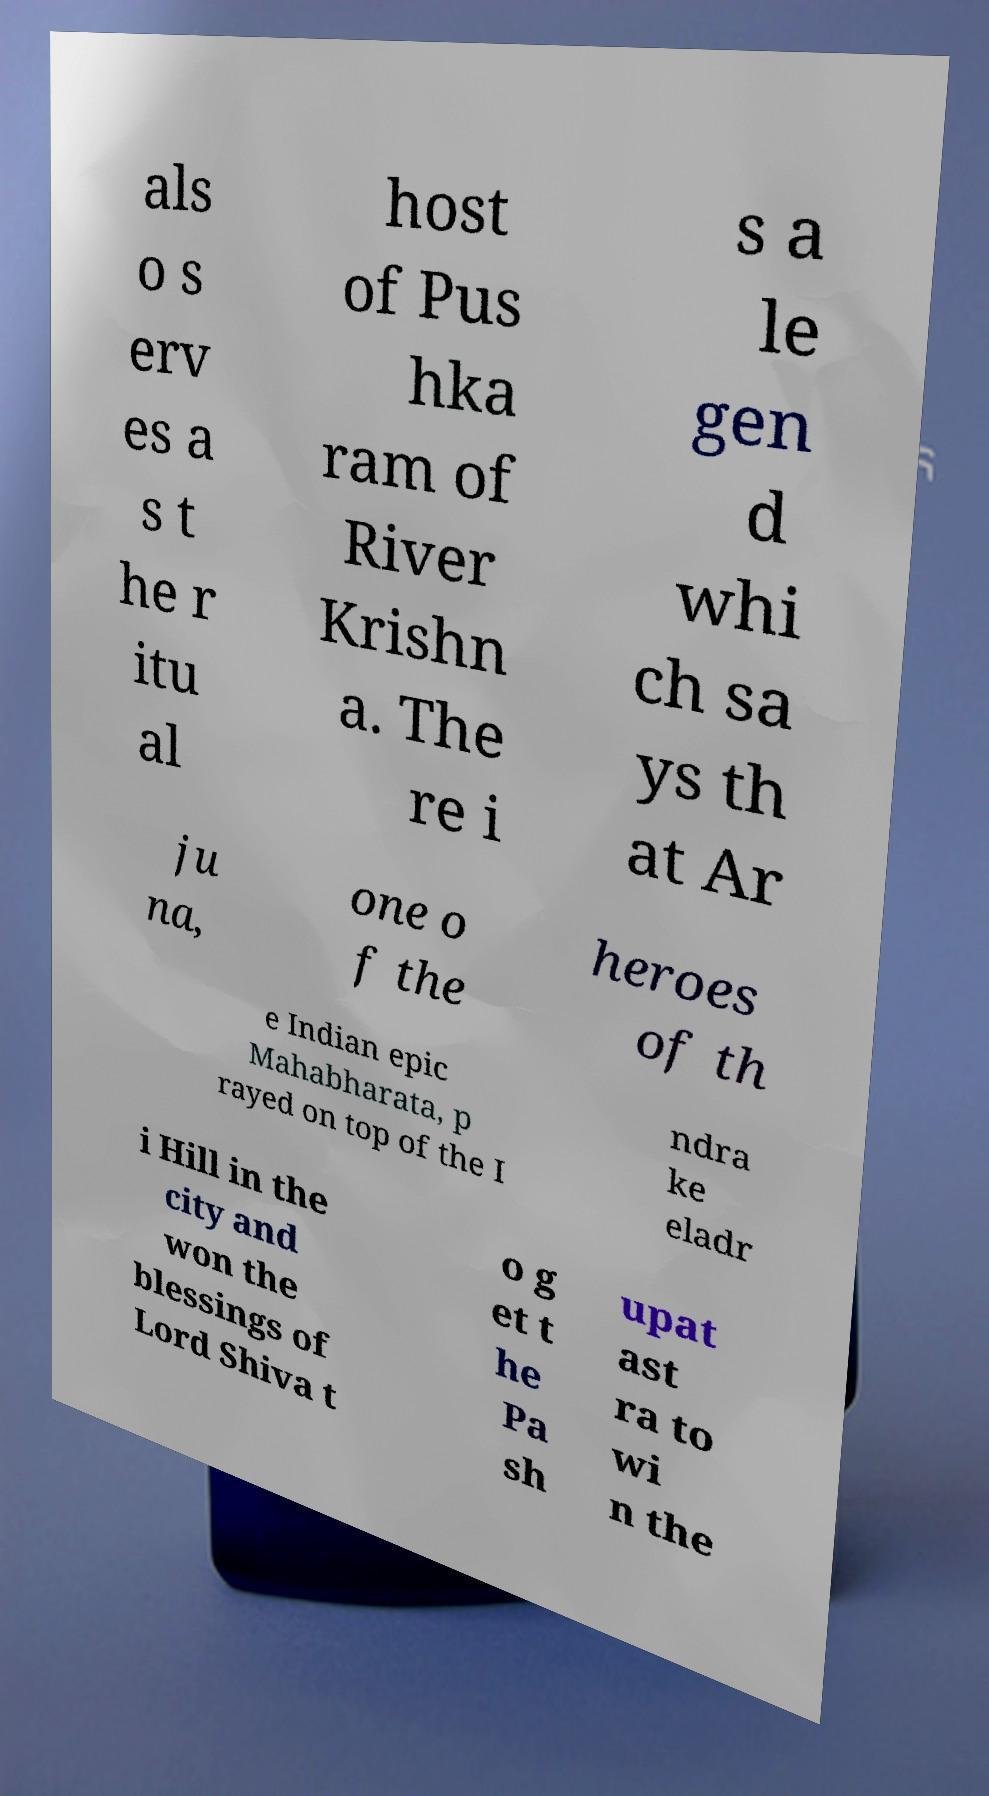For documentation purposes, I need the text within this image transcribed. Could you provide that? als o s erv es a s t he r itu al host of Pus hka ram of River Krishn a. The re i s a le gen d whi ch sa ys th at Ar ju na, one o f the heroes of th e Indian epic Mahabharata, p rayed on top of the I ndra ke eladr i Hill in the city and won the blessings of Lord Shiva t o g et t he Pa sh upat ast ra to wi n the 